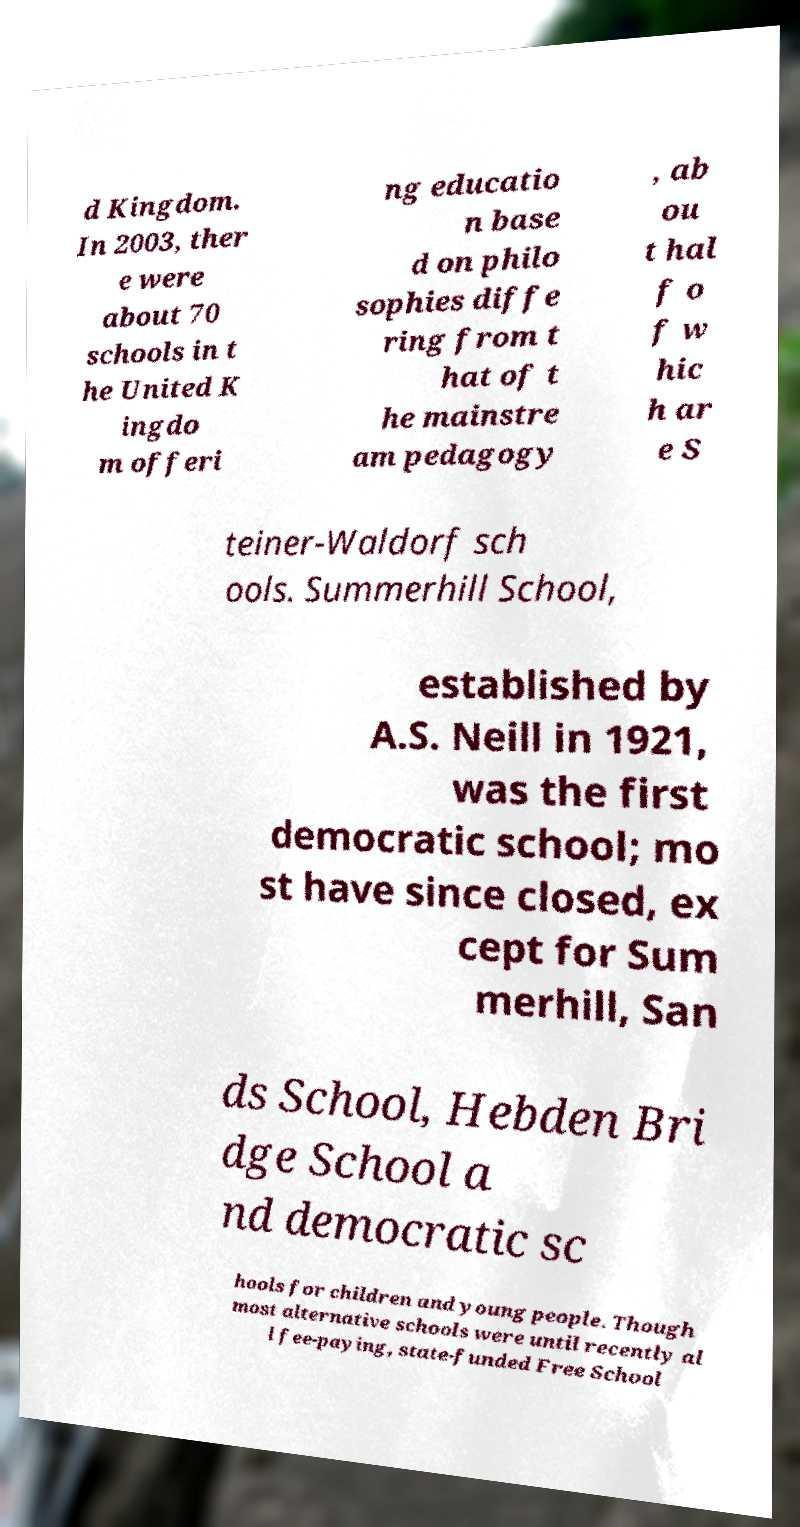What messages or text are displayed in this image? I need them in a readable, typed format. d Kingdom. In 2003, ther e were about 70 schools in t he United K ingdo m offeri ng educatio n base d on philo sophies diffe ring from t hat of t he mainstre am pedagogy , ab ou t hal f o f w hic h ar e S teiner-Waldorf sch ools. Summerhill School, established by A.S. Neill in 1921, was the first democratic school; mo st have since closed, ex cept for Sum merhill, San ds School, Hebden Bri dge School a nd democratic sc hools for children and young people. Though most alternative schools were until recently al l fee-paying, state-funded Free School 